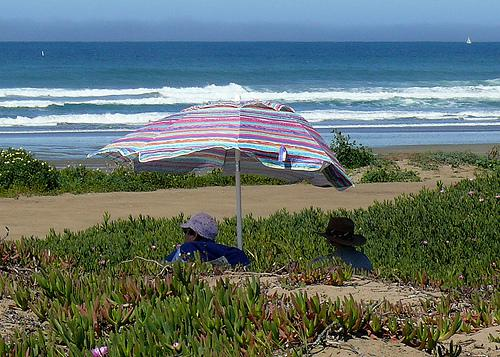Question: why is the umbrella being used?
Choices:
A. It's raining.
B. Protect people.
C. Keep dry.
D. For shade.
Answer with the letter. Answer: D Question: where is the photo taken?
Choices:
A. Park.
B. Forest.
C. Beach.
D. Lake.
Answer with the letter. Answer: C 